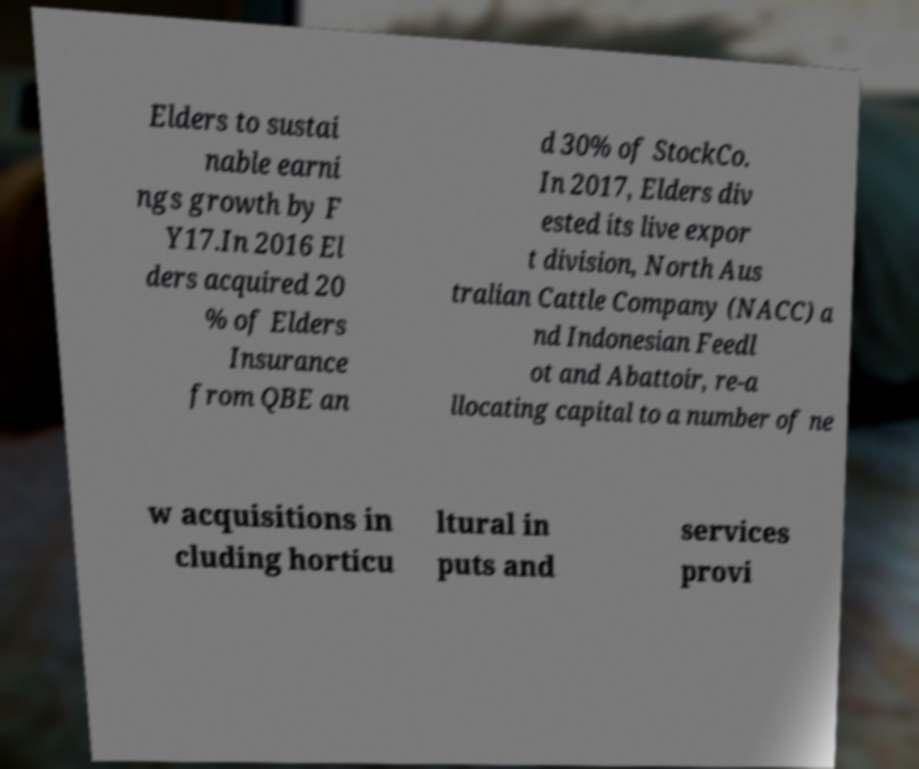There's text embedded in this image that I need extracted. Can you transcribe it verbatim? Elders to sustai nable earni ngs growth by F Y17.In 2016 El ders acquired 20 % of Elders Insurance from QBE an d 30% of StockCo. In 2017, Elders div ested its live expor t division, North Aus tralian Cattle Company (NACC) a nd Indonesian Feedl ot and Abattoir, re-a llocating capital to a number of ne w acquisitions in cluding horticu ltural in puts and services provi 